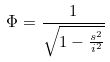<formula> <loc_0><loc_0><loc_500><loc_500>\Phi = \frac { 1 } { \sqrt { 1 - \frac { s ^ { 2 } } { i ^ { 2 } } } }</formula> 